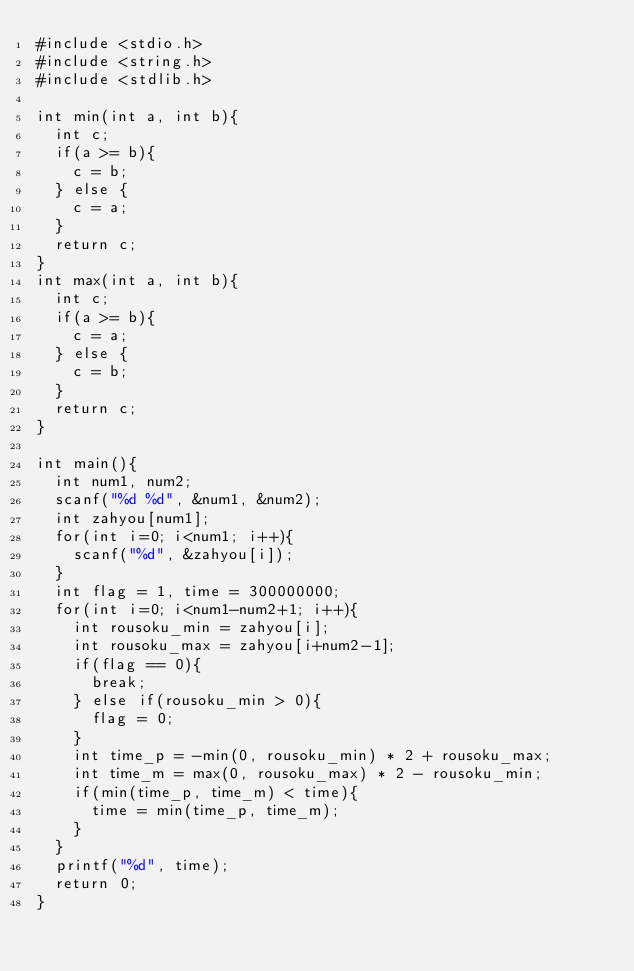Convert code to text. <code><loc_0><loc_0><loc_500><loc_500><_C_>#include <stdio.h>
#include <string.h>
#include <stdlib.h>

int min(int a, int b){
  int c;
  if(a >= b){
    c = b;
  } else {
    c = a;
  }
  return c;
}
int max(int a, int b){
  int c;
  if(a >= b){
    c = a;
  } else {
    c = b;
  }
  return c;
}

int main(){
  int num1, num2;
  scanf("%d %d", &num1, &num2);
  int zahyou[num1];
  for(int i=0; i<num1; i++){
    scanf("%d", &zahyou[i]);
  }
  int flag = 1, time = 300000000;
  for(int i=0; i<num1-num2+1; i++){
    int rousoku_min = zahyou[i];
    int rousoku_max = zahyou[i+num2-1];
    if(flag == 0){
      break;
    } else if(rousoku_min > 0){
      flag = 0;
    }
    int time_p = -min(0, rousoku_min) * 2 + rousoku_max;
    int time_m = max(0, rousoku_max) * 2 - rousoku_min;
    if(min(time_p, time_m) < time){
      time = min(time_p, time_m);
    }
  }
  printf("%d", time);
  return 0;
}
</code> 